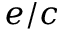Convert formula to latex. <formula><loc_0><loc_0><loc_500><loc_500>e / c</formula> 